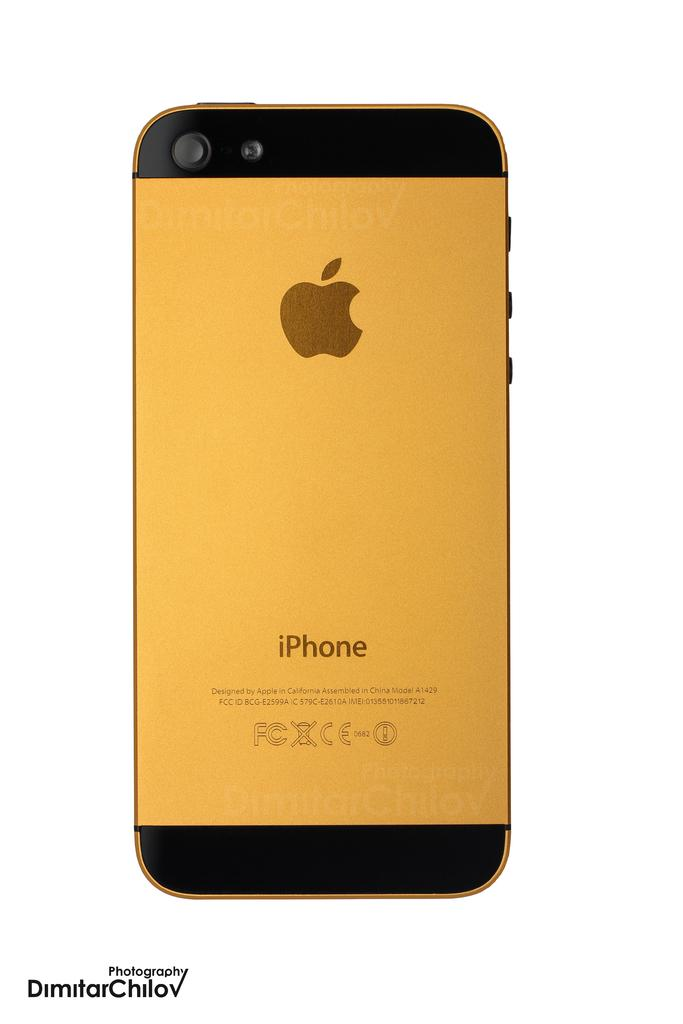<image>
Create a compact narrative representing the image presented. A gold colored iPhone with a white background by DimitarChilov Photography. 